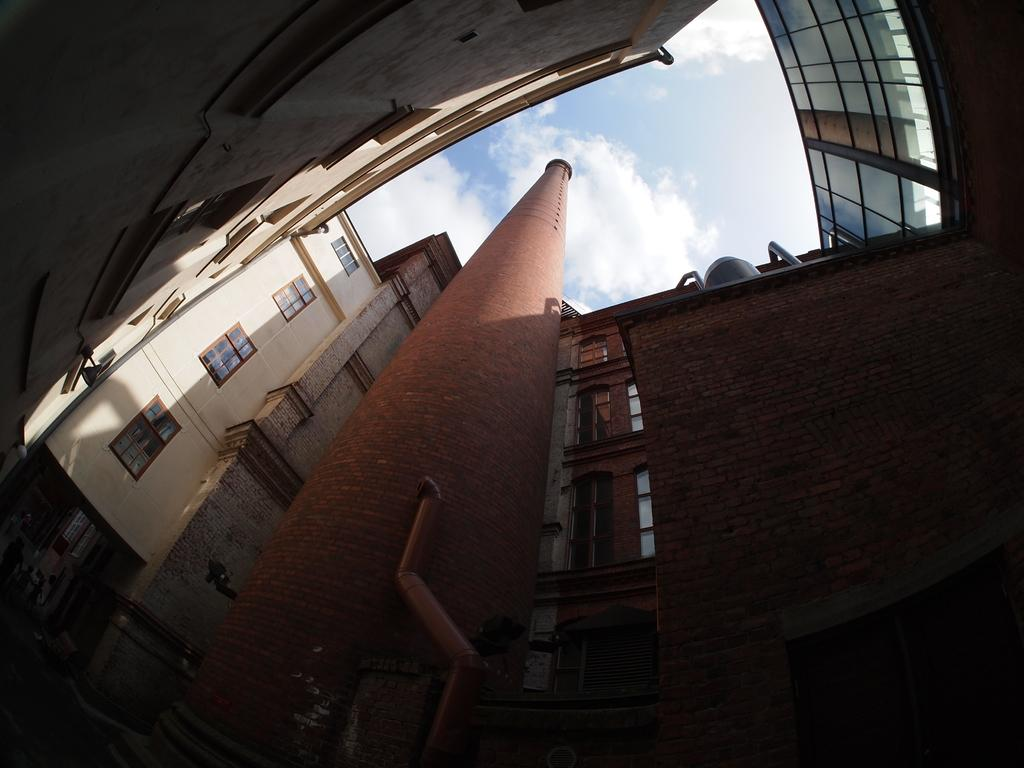What type of structures are present in the image? There are buildings in the image. What feature do the buildings have? The buildings have windows. What is visible in the background of the image? The sky is visible in the image. What colors can be seen in the sky? The sky has a white and blue color. What is the color of the brown object in the image? The brown object in the image is brown. What adjustment can be made to the caption of the image? There is no caption present in the image, so no adjustment can be made. 